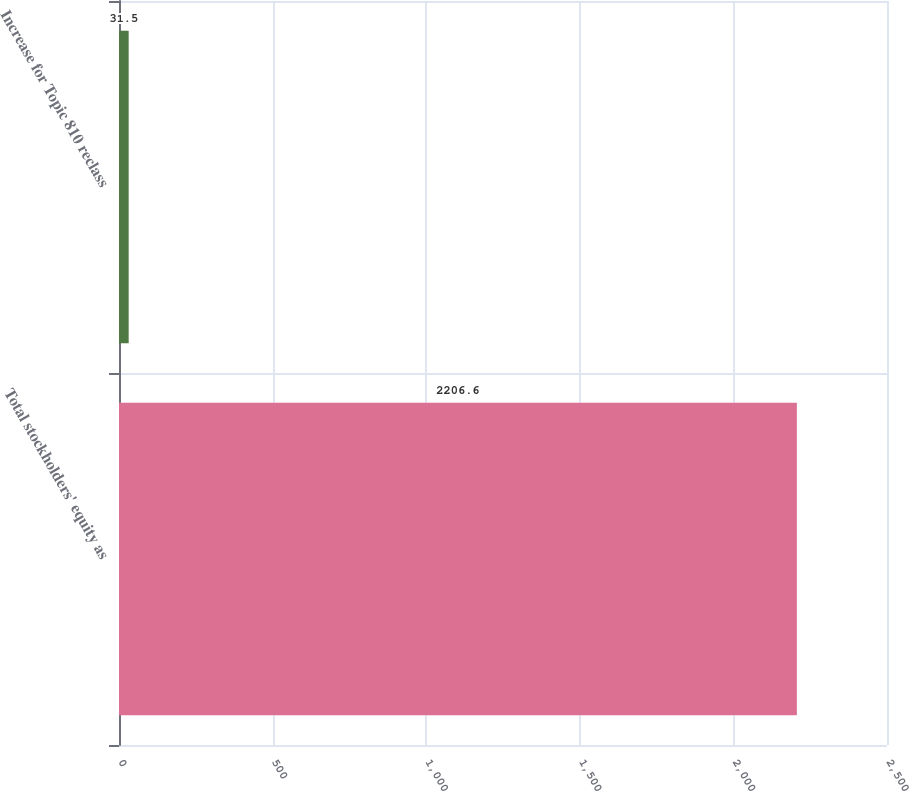<chart> <loc_0><loc_0><loc_500><loc_500><bar_chart><fcel>Total stockholders' equity as<fcel>Increase for Topic 810 reclass<nl><fcel>2206.6<fcel>31.5<nl></chart> 